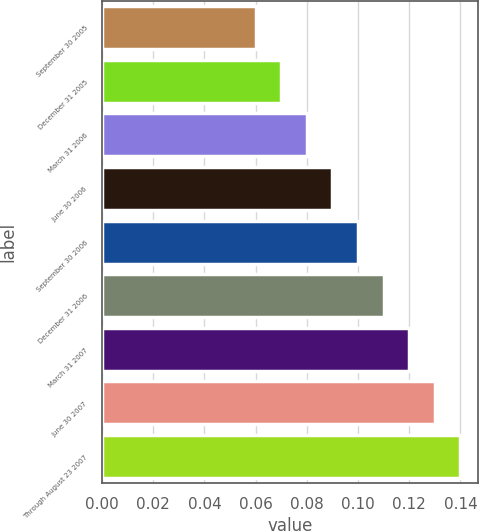Convert chart. <chart><loc_0><loc_0><loc_500><loc_500><bar_chart><fcel>September 30 2005<fcel>December 31 2005<fcel>March 31 2006<fcel>June 30 2006<fcel>September 30 2006<fcel>December 31 2006<fcel>March 31 2007<fcel>June 30 2007<fcel>Through August 23 2007<nl><fcel>0.06<fcel>0.07<fcel>0.08<fcel>0.09<fcel>0.1<fcel>0.11<fcel>0.12<fcel>0.13<fcel>0.14<nl></chart> 